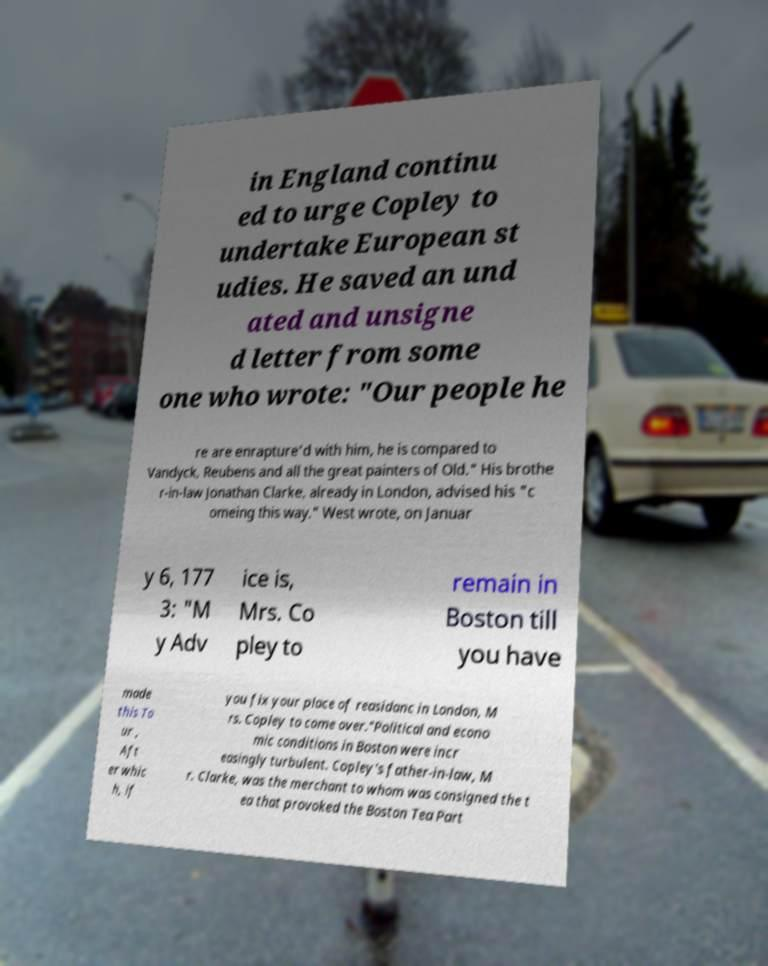Could you extract and type out the text from this image? in England continu ed to urge Copley to undertake European st udies. He saved an und ated and unsigne d letter from some one who wrote: "Our people he re are enrapture'd with him, he is compared to Vandyck, Reubens and all the great painters of Old." His brothe r-in-law Jonathan Clarke, already in London, advised his "c omeing this way." West wrote, on Januar y 6, 177 3: "M y Adv ice is, Mrs. Co pley to remain in Boston till you have made this To ur , Aft er whic h, if you fix your place of reasidanc in London, M rs. Copley to come over."Political and econo mic conditions in Boston were incr easingly turbulent. Copley's father-in-law, M r. Clarke, was the merchant to whom was consigned the t ea that provoked the Boston Tea Part 